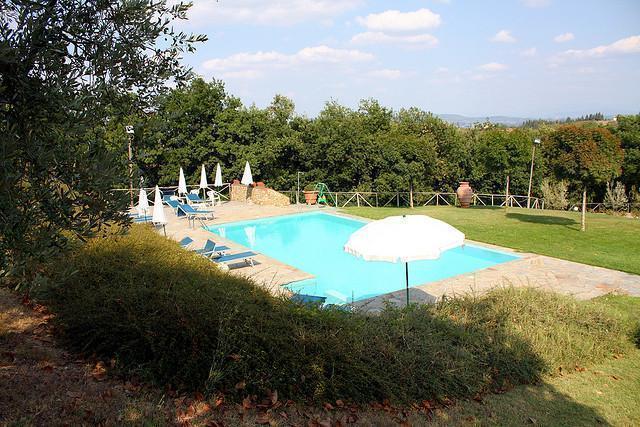Where is this pool located at?
Pick the right solution, then justify: 'Answer: answer
Rationale: rationale.'
Options: Resort, public park, winery, backyard. Answer: backyard.
Rationale: This looks like a private pool. 